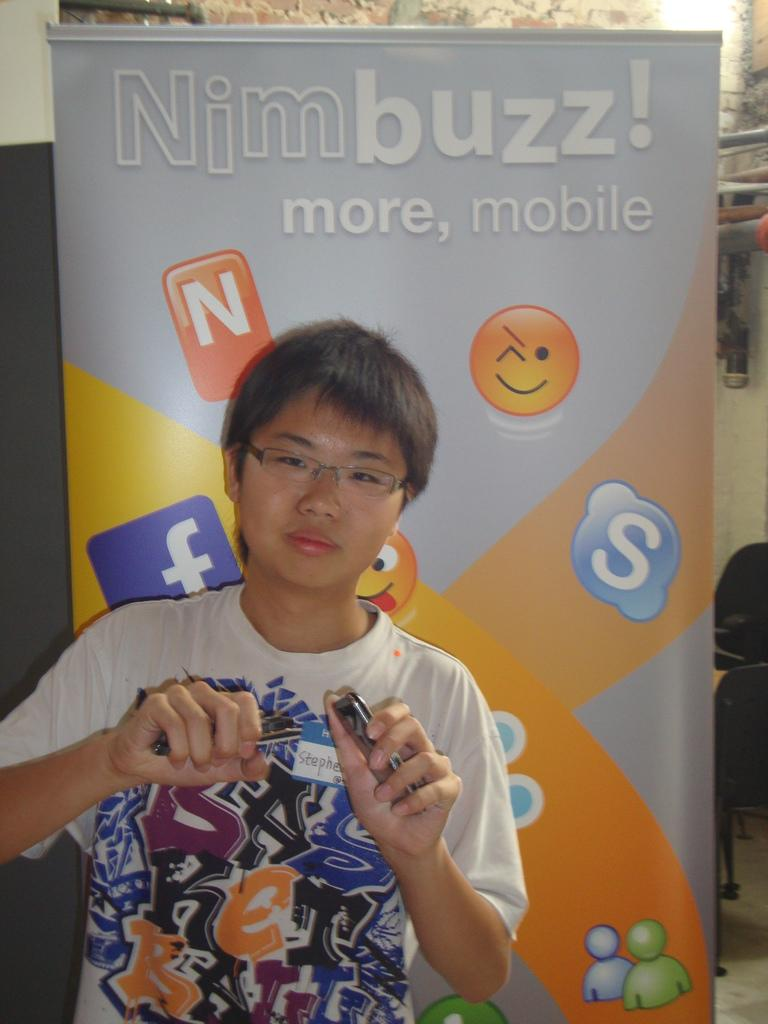<image>
Give a short and clear explanation of the subsequent image. Several applications icons are displayed on an advertisement with Nimbuzz! written aove it. 